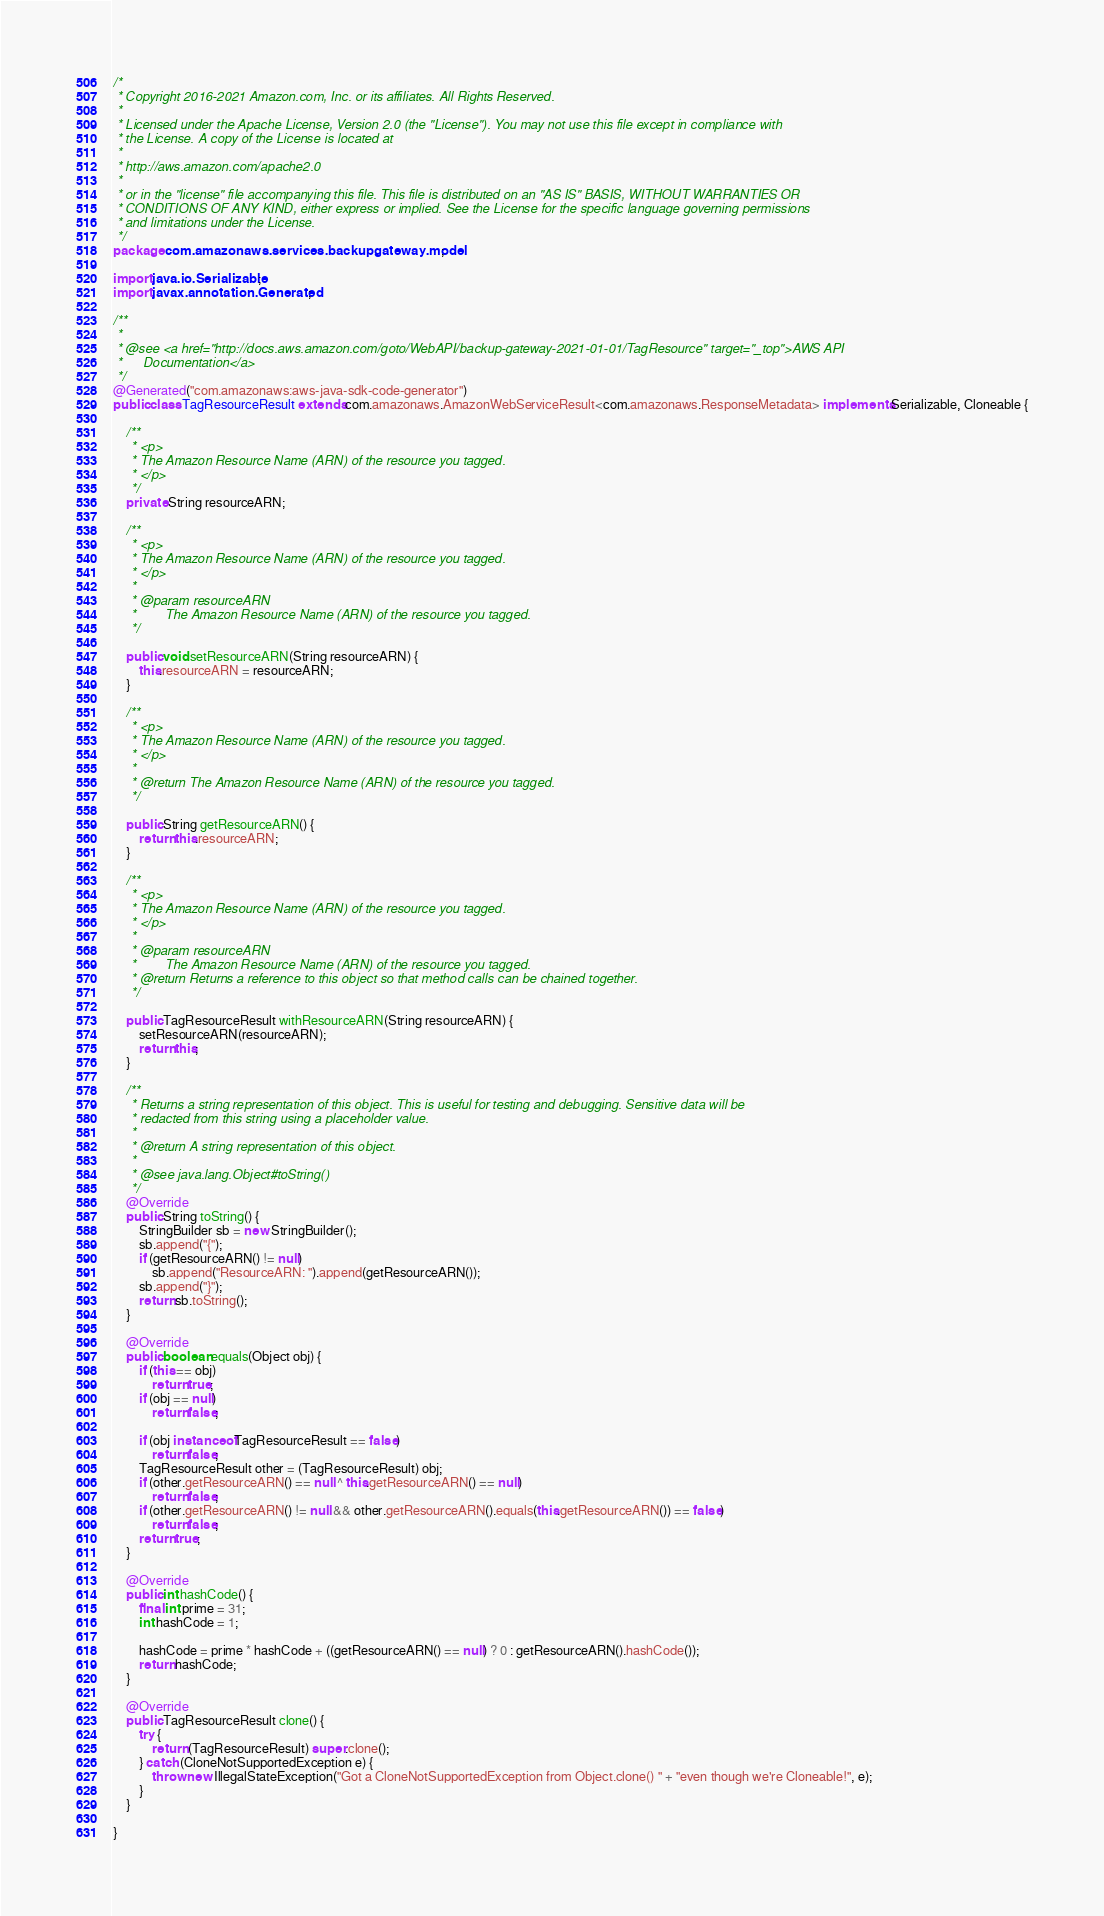<code> <loc_0><loc_0><loc_500><loc_500><_Java_>/*
 * Copyright 2016-2021 Amazon.com, Inc. or its affiliates. All Rights Reserved.
 * 
 * Licensed under the Apache License, Version 2.0 (the "License"). You may not use this file except in compliance with
 * the License. A copy of the License is located at
 * 
 * http://aws.amazon.com/apache2.0
 * 
 * or in the "license" file accompanying this file. This file is distributed on an "AS IS" BASIS, WITHOUT WARRANTIES OR
 * CONDITIONS OF ANY KIND, either express or implied. See the License for the specific language governing permissions
 * and limitations under the License.
 */
package com.amazonaws.services.backupgateway.model;

import java.io.Serializable;
import javax.annotation.Generated;

/**
 * 
 * @see <a href="http://docs.aws.amazon.com/goto/WebAPI/backup-gateway-2021-01-01/TagResource" target="_top">AWS API
 *      Documentation</a>
 */
@Generated("com.amazonaws:aws-java-sdk-code-generator")
public class TagResourceResult extends com.amazonaws.AmazonWebServiceResult<com.amazonaws.ResponseMetadata> implements Serializable, Cloneable {

    /**
     * <p>
     * The Amazon Resource Name (ARN) of the resource you tagged.
     * </p>
     */
    private String resourceARN;

    /**
     * <p>
     * The Amazon Resource Name (ARN) of the resource you tagged.
     * </p>
     * 
     * @param resourceARN
     *        The Amazon Resource Name (ARN) of the resource you tagged.
     */

    public void setResourceARN(String resourceARN) {
        this.resourceARN = resourceARN;
    }

    /**
     * <p>
     * The Amazon Resource Name (ARN) of the resource you tagged.
     * </p>
     * 
     * @return The Amazon Resource Name (ARN) of the resource you tagged.
     */

    public String getResourceARN() {
        return this.resourceARN;
    }

    /**
     * <p>
     * The Amazon Resource Name (ARN) of the resource you tagged.
     * </p>
     * 
     * @param resourceARN
     *        The Amazon Resource Name (ARN) of the resource you tagged.
     * @return Returns a reference to this object so that method calls can be chained together.
     */

    public TagResourceResult withResourceARN(String resourceARN) {
        setResourceARN(resourceARN);
        return this;
    }

    /**
     * Returns a string representation of this object. This is useful for testing and debugging. Sensitive data will be
     * redacted from this string using a placeholder value.
     *
     * @return A string representation of this object.
     *
     * @see java.lang.Object#toString()
     */
    @Override
    public String toString() {
        StringBuilder sb = new StringBuilder();
        sb.append("{");
        if (getResourceARN() != null)
            sb.append("ResourceARN: ").append(getResourceARN());
        sb.append("}");
        return sb.toString();
    }

    @Override
    public boolean equals(Object obj) {
        if (this == obj)
            return true;
        if (obj == null)
            return false;

        if (obj instanceof TagResourceResult == false)
            return false;
        TagResourceResult other = (TagResourceResult) obj;
        if (other.getResourceARN() == null ^ this.getResourceARN() == null)
            return false;
        if (other.getResourceARN() != null && other.getResourceARN().equals(this.getResourceARN()) == false)
            return false;
        return true;
    }

    @Override
    public int hashCode() {
        final int prime = 31;
        int hashCode = 1;

        hashCode = prime * hashCode + ((getResourceARN() == null) ? 0 : getResourceARN().hashCode());
        return hashCode;
    }

    @Override
    public TagResourceResult clone() {
        try {
            return (TagResourceResult) super.clone();
        } catch (CloneNotSupportedException e) {
            throw new IllegalStateException("Got a CloneNotSupportedException from Object.clone() " + "even though we're Cloneable!", e);
        }
    }

}
</code> 